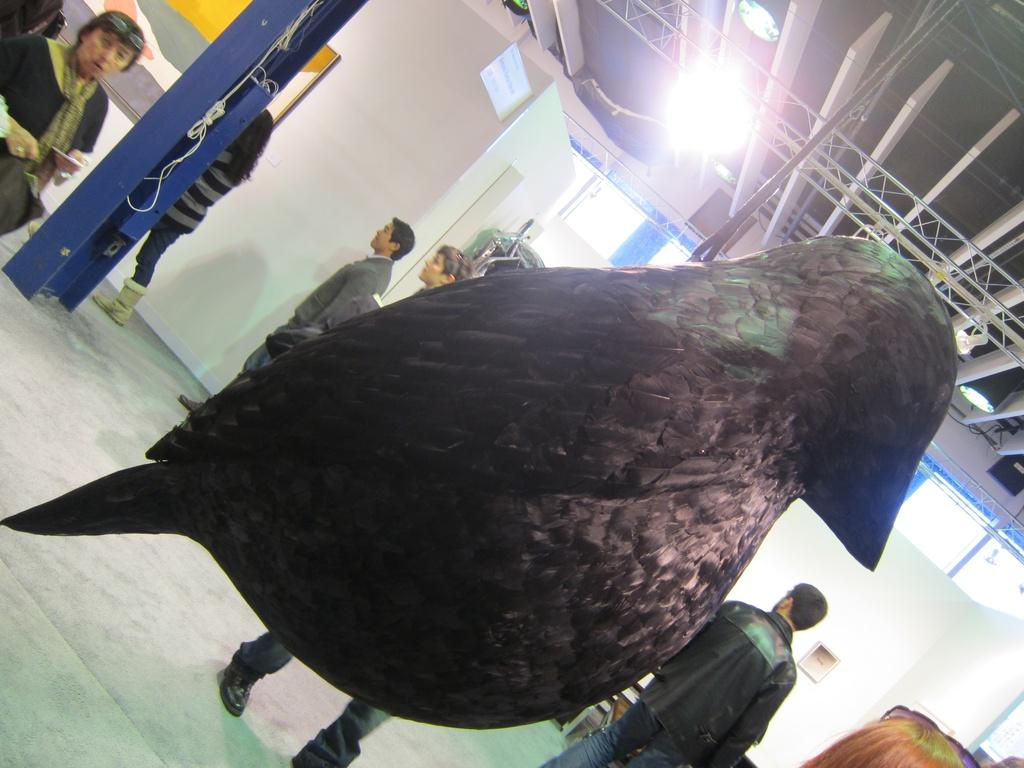What is the main subject of the image? There is a statue of a bird in the image. What can be seen in the background of the image? There are people on the floor in the background of the image. What type of objects are visible in the image? There are boards visible in the image. Can you describe the objects present in the image? There are some objects present in the image, but their specific nature is not mentioned in the provided facts. What type of beef is being served at the houses in the image? There is no mention of beef or houses in the image; it features a statue of a bird and people on the floor in the background. 